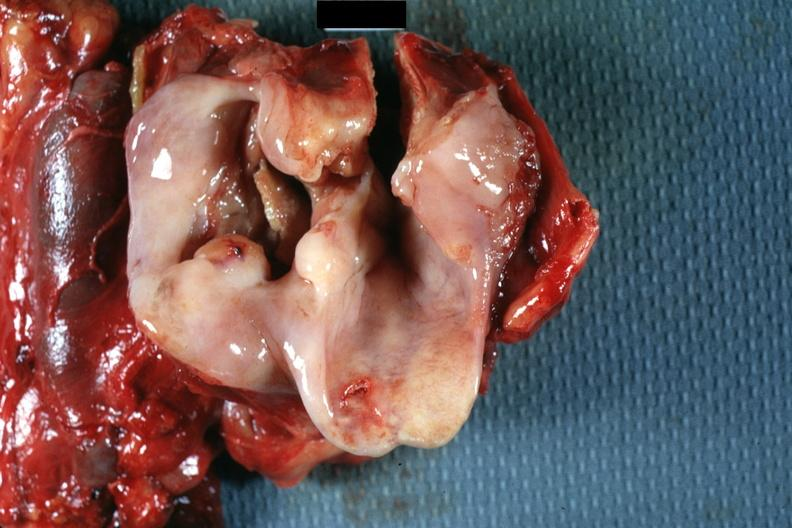what does this image show?
Answer the question using a single word or phrase. Large ulcerative lesion in pyriform sinus natural color 